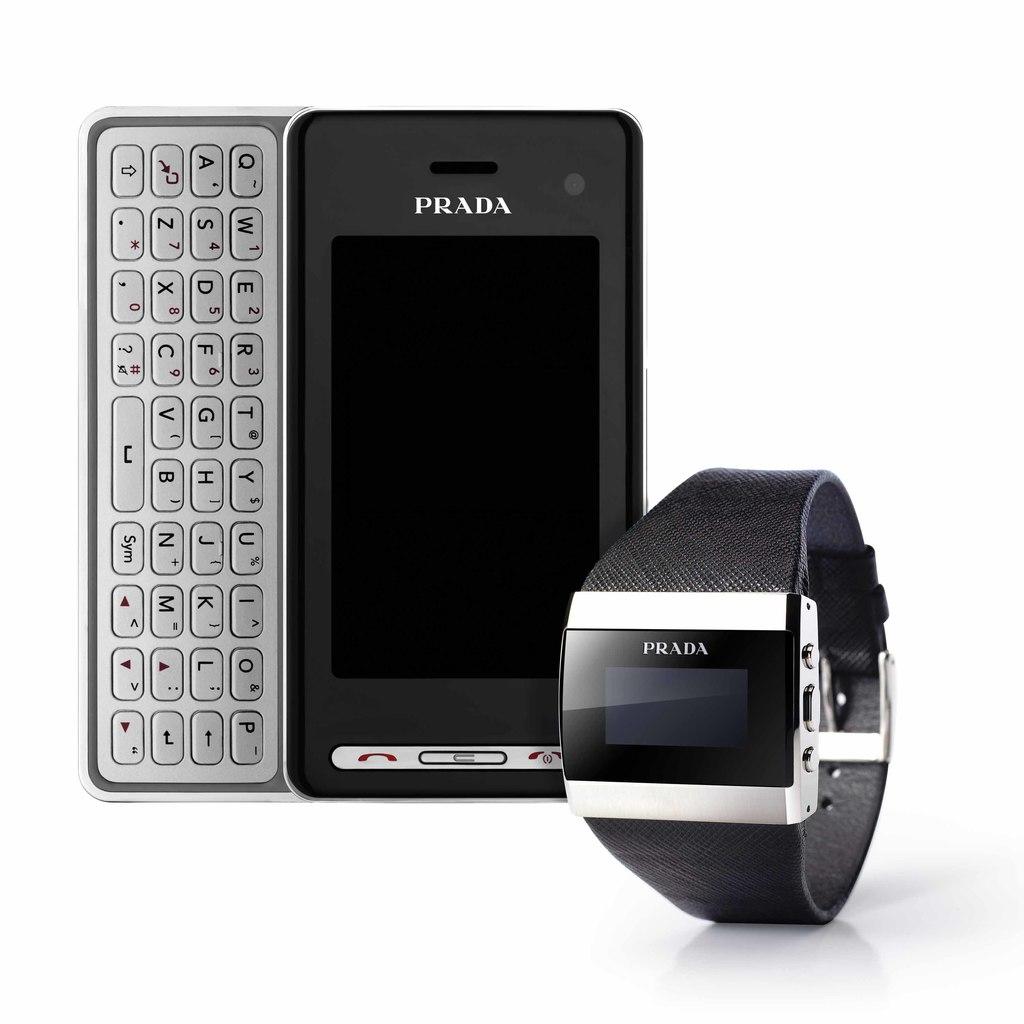Does prada make more electronics?
Ensure brevity in your answer.  Answering does not require reading text in the image. What brand name is on the devices?
Keep it short and to the point. Prada. 